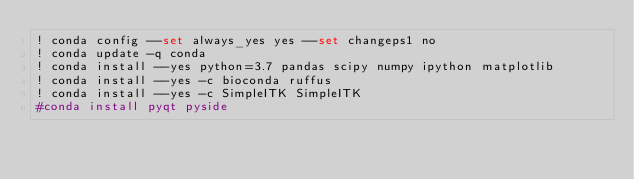<code> <loc_0><loc_0><loc_500><loc_500><_Bash_>! conda config --set always_yes yes --set changeps1 no
! conda update -q conda
! conda install --yes python=3.7 pandas scipy numpy ipython matplotlib
! conda install --yes -c bioconda ruffus
! conda install --yes -c SimpleITK SimpleITK 
#conda install pyqt pyside
</code> 